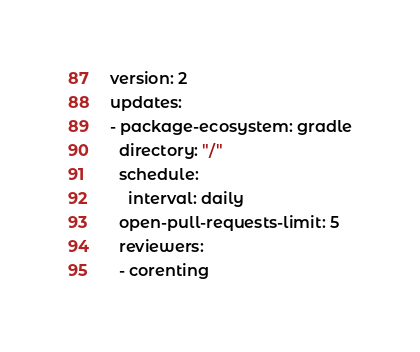Convert code to text. <code><loc_0><loc_0><loc_500><loc_500><_YAML_>version: 2
updates:
- package-ecosystem: gradle
  directory: "/"
  schedule:
    interval: daily
  open-pull-requests-limit: 5
  reviewers:
  - corenting
</code> 